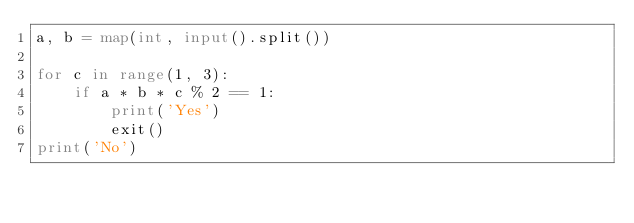Convert code to text. <code><loc_0><loc_0><loc_500><loc_500><_Python_>a, b = map(int, input().split())

for c in range(1, 3):
    if a * b * c % 2 == 1:
        print('Yes')
        exit()
print('No')</code> 